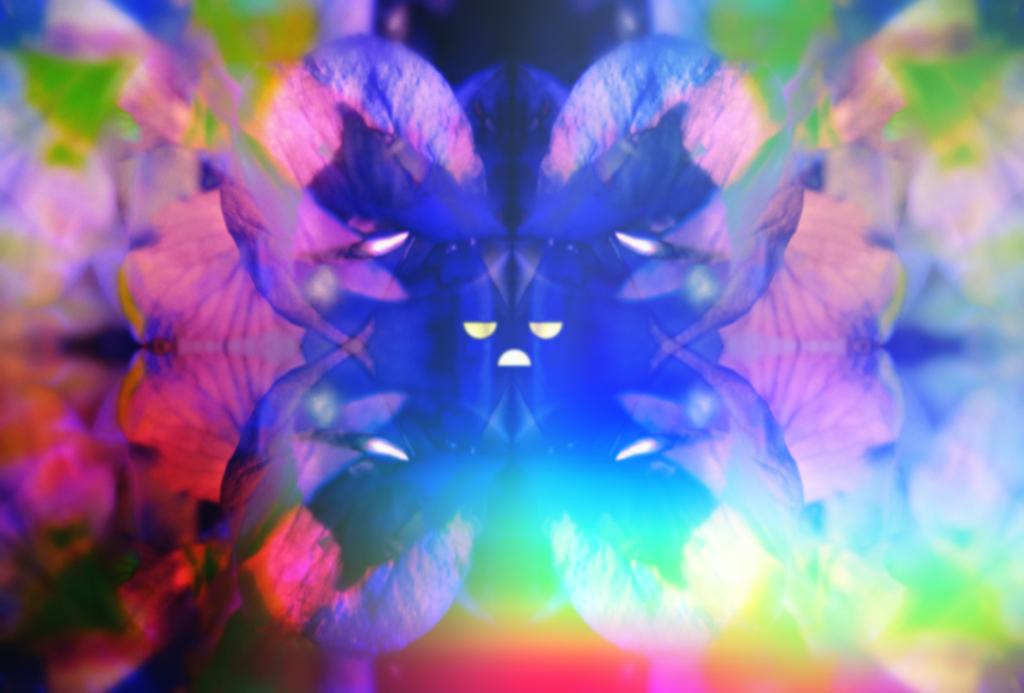What type of living organisms can be seen in the image? There are flowers in the image. What type of range can be seen in the image? There is no range present in the image; it only features flowers. How many beds are visible in the image? There are no beds present in the image; it only features flowers. 